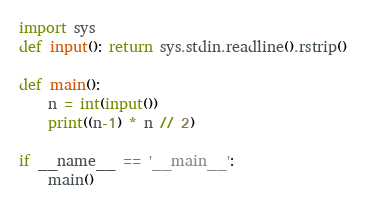Convert code to text. <code><loc_0><loc_0><loc_500><loc_500><_Python_>import sys
def input(): return sys.stdin.readline().rstrip()

def main():
    n = int(input())
    print((n-1) * n // 2)

if __name__ == '__main__':
    main()
</code> 